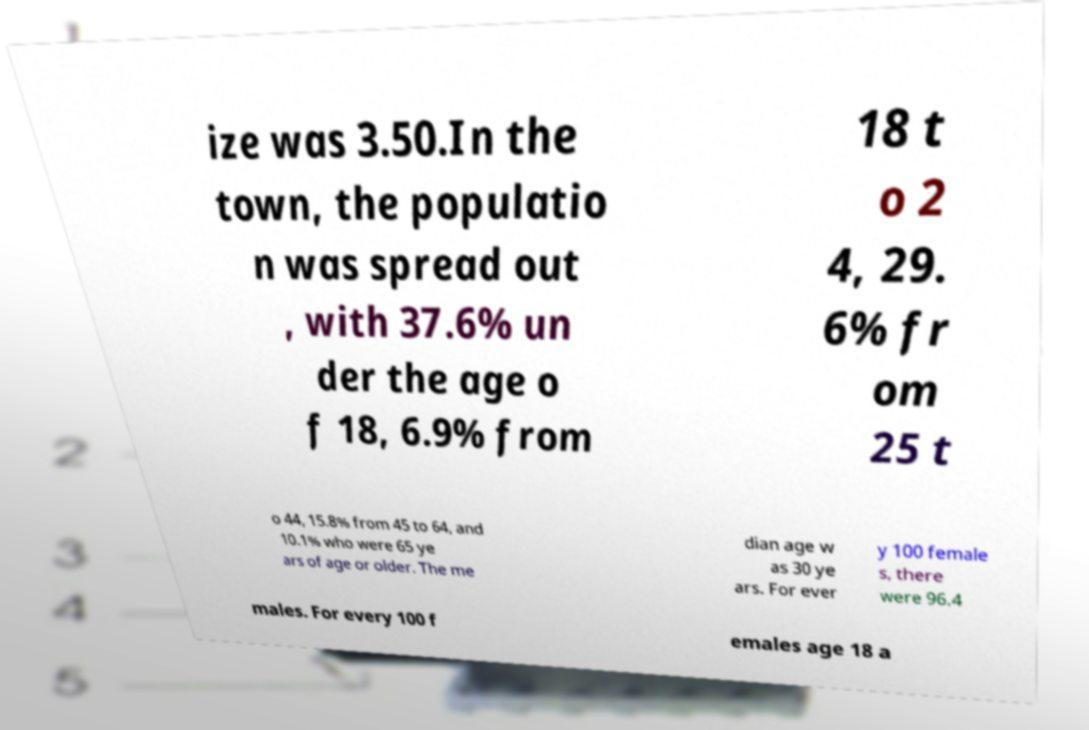There's text embedded in this image that I need extracted. Can you transcribe it verbatim? ize was 3.50.In the town, the populatio n was spread out , with 37.6% un der the age o f 18, 6.9% from 18 t o 2 4, 29. 6% fr om 25 t o 44, 15.8% from 45 to 64, and 10.1% who were 65 ye ars of age or older. The me dian age w as 30 ye ars. For ever y 100 female s, there were 96.4 males. For every 100 f emales age 18 a 